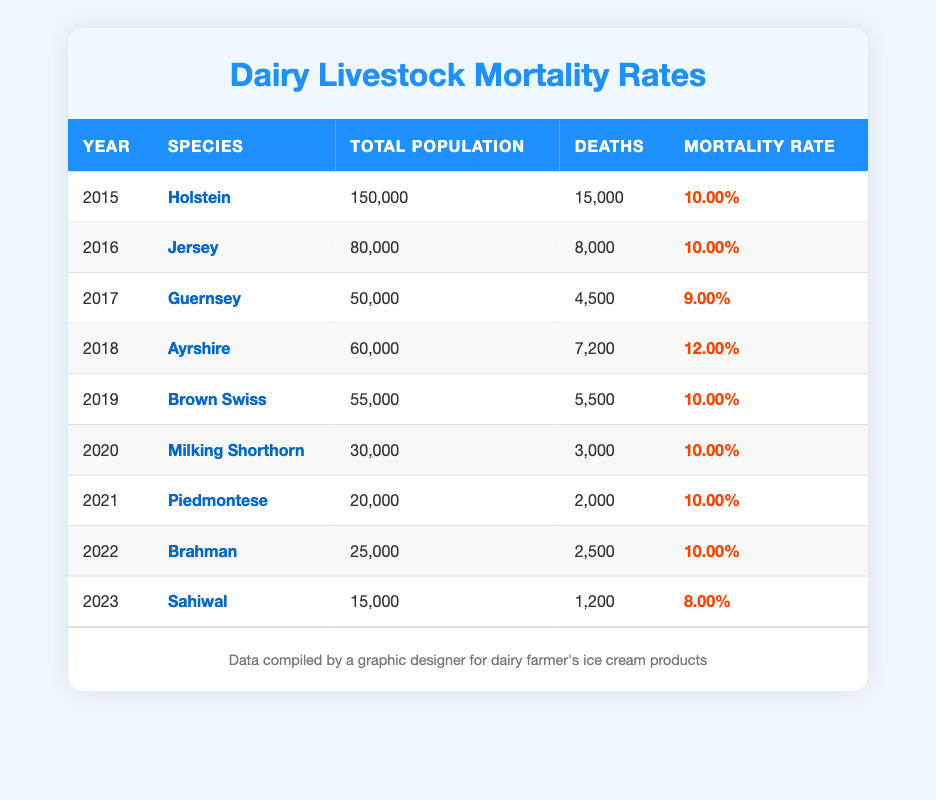What was the mortality rate for Holsteins in 2015? Looking at the table, the row for the year 2015 shows that the mortality rate for Holsteins is 10.00%.
Answer: 10.00% Which species had the highest mortality rate? From the table, Ayrshire in 2018 has a mortality rate of 12.00%, which is the highest compared to all other entries.
Answer: Ayrshire in 2018 What was the total number of deaths for Jersey in 2016? Referring to the table, in the year 2016, Jersey had a total of 8,000 deaths listed.
Answer: 8,000 What is the average mortality rate of all species over the years? To find the average mortality rate, we sum the mortality rates: (10.00 + 10.00 + 9.00 + 12.00 + 10.00 + 10.00 + 10.00 + 10.00 + 8.00) = 9.78%. Dividing by the 9 species gives us an average of approximately 10.00%.
Answer: 10.00% Was the mortality rate for Sahiwal in 2023 lower than 10%? The table shows that the mortality rate for Sahiwal in 2023 is 8.00%, which is indeed lower than 10%.
Answer: Yes What was the total population of Brahman in 2022? The table indicates that in 2022, the total population of Brahman was 25,000.
Answer: 25,000 Did the mortality rate increase or decrease from 2018 to 2019? In 2018, the mortality rate was 12.00%, and in 2019 it was 10.00%. This indicates a decrease between those years.
Answer: Decrease Which species had the lowest number of deaths recorded? Checking the table, Sahiwal in 2023 had the lowest number of deaths at 1,200.
Answer: Sahiwal in 2023 What is the total number of deaths from 2015 to 2021? To find this, we sum the deaths: (15,000 + 8,000 + 4,500 + 7,200 + 5,500 + 3,000 + 2,000) = 45,200 deaths from 2015 to 2021.
Answer: 45,200 